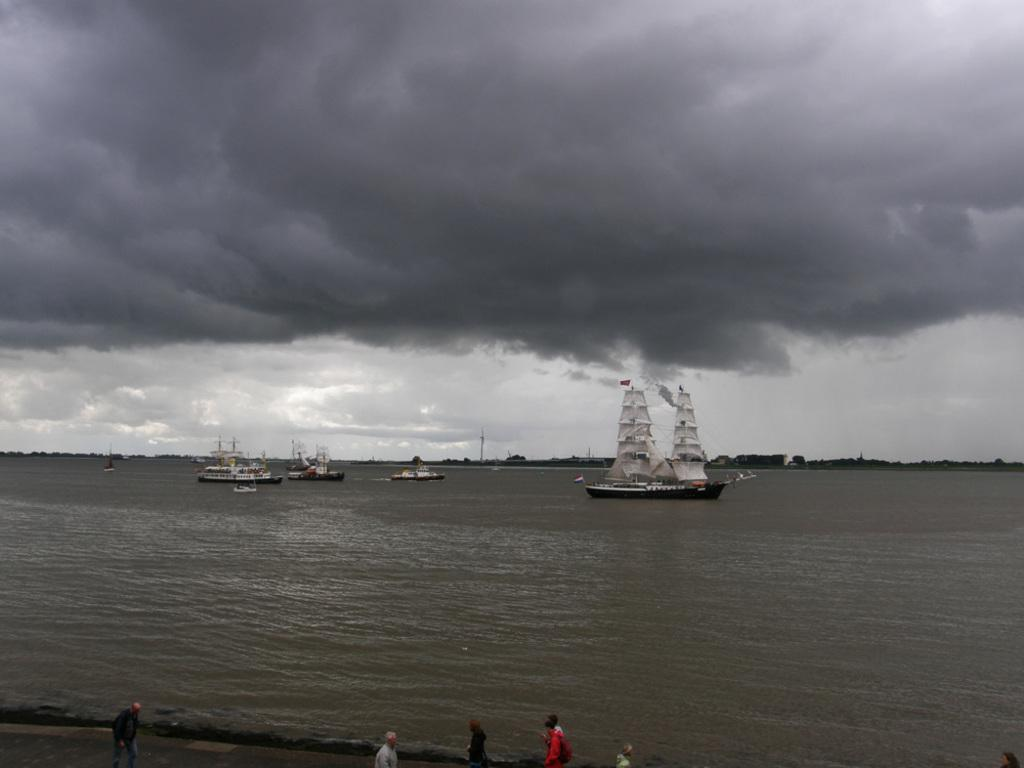What is happening at the bottom of the image? There is a group of people at the bottom of the image. What can be seen in the background of the image? There are ships visible in the background of the image. What is the ships' location in relation to the water? The ships are on water. What is visible in the sky in the image? There are clouds visible in the image. How many horses are present in the image? There are no horses present in the image. What type of haircut does the person in the group have? There is no specific person mentioned in the image, and no information about haircuts is provided. 